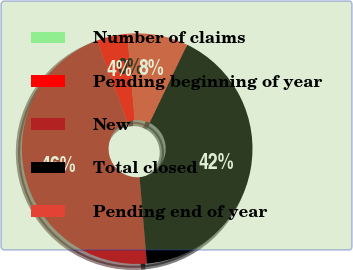<chart> <loc_0><loc_0><loc_500><loc_500><pie_chart><fcel>Number of claims<fcel>Pending beginning of year<fcel>New<fcel>Total closed<fcel>Pending end of year<nl><fcel>0.02%<fcel>4.31%<fcel>45.68%<fcel>41.52%<fcel>8.48%<nl></chart> 